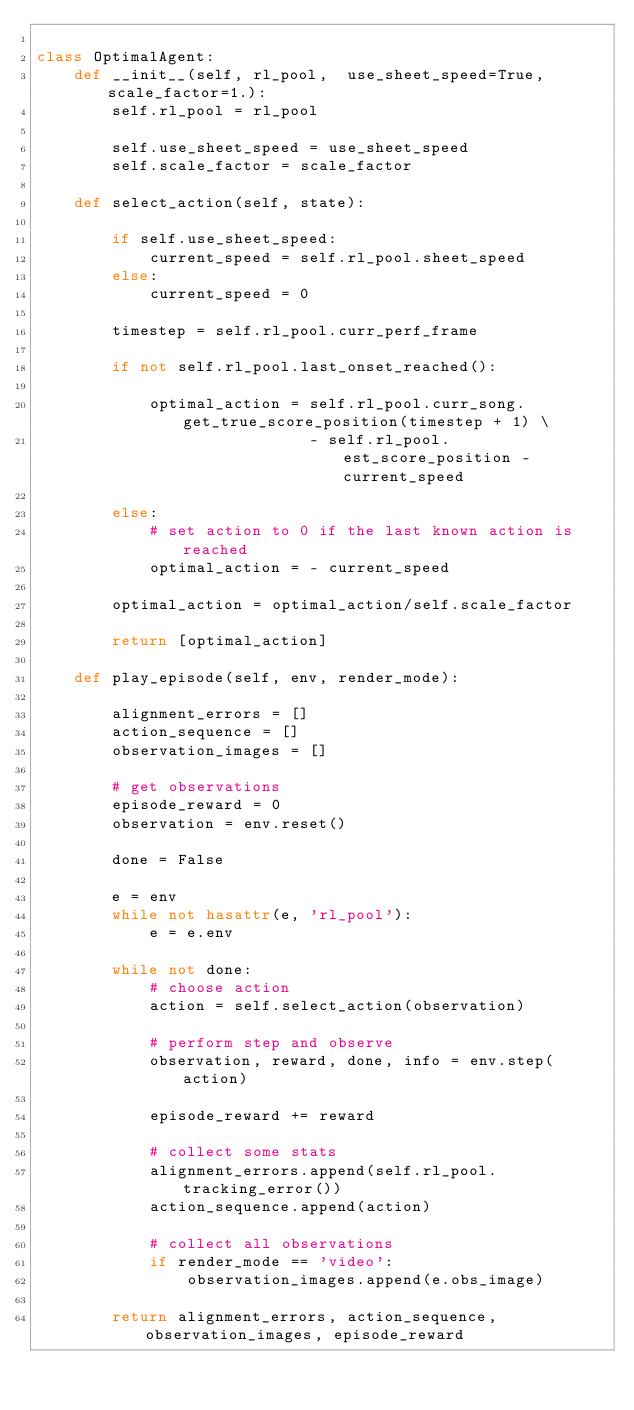<code> <loc_0><loc_0><loc_500><loc_500><_Python_>
class OptimalAgent:
    def __init__(self, rl_pool,  use_sheet_speed=True, scale_factor=1.):
        self.rl_pool = rl_pool

        self.use_sheet_speed = use_sheet_speed
        self.scale_factor = scale_factor

    def select_action(self, state):

        if self.use_sheet_speed:
            current_speed = self.rl_pool.sheet_speed
        else:
            current_speed = 0

        timestep = self.rl_pool.curr_perf_frame

        if not self.rl_pool.last_onset_reached():

            optimal_action = self.rl_pool.curr_song.get_true_score_position(timestep + 1) \
                             - self.rl_pool.est_score_position - current_speed

        else:
            # set action to 0 if the last known action is reached
            optimal_action = - current_speed

        optimal_action = optimal_action/self.scale_factor

        return [optimal_action]

    def play_episode(self, env, render_mode):

        alignment_errors = []
        action_sequence = []
        observation_images = []

        # get observations
        episode_reward = 0
        observation = env.reset()

        done = False

        e = env
        while not hasattr(e, 'rl_pool'):
            e = e.env

        while not done:
            # choose action
            action = self.select_action(observation)

            # perform step and observe
            observation, reward, done, info = env.step(action)

            episode_reward += reward

            # collect some stats
            alignment_errors.append(self.rl_pool.tracking_error())
            action_sequence.append(action)

            # collect all observations
            if render_mode == 'video':
                observation_images.append(e.obs_image)

        return alignment_errors, action_sequence, observation_images, episode_reward
</code> 